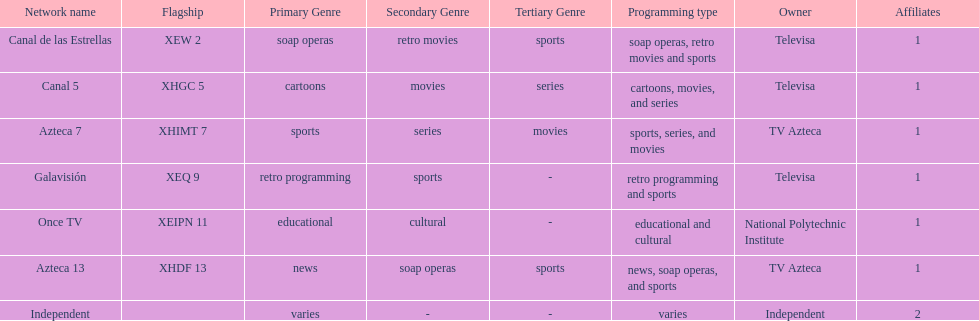Who is the only network owner listed in a consecutive order in the chart? Televisa. 